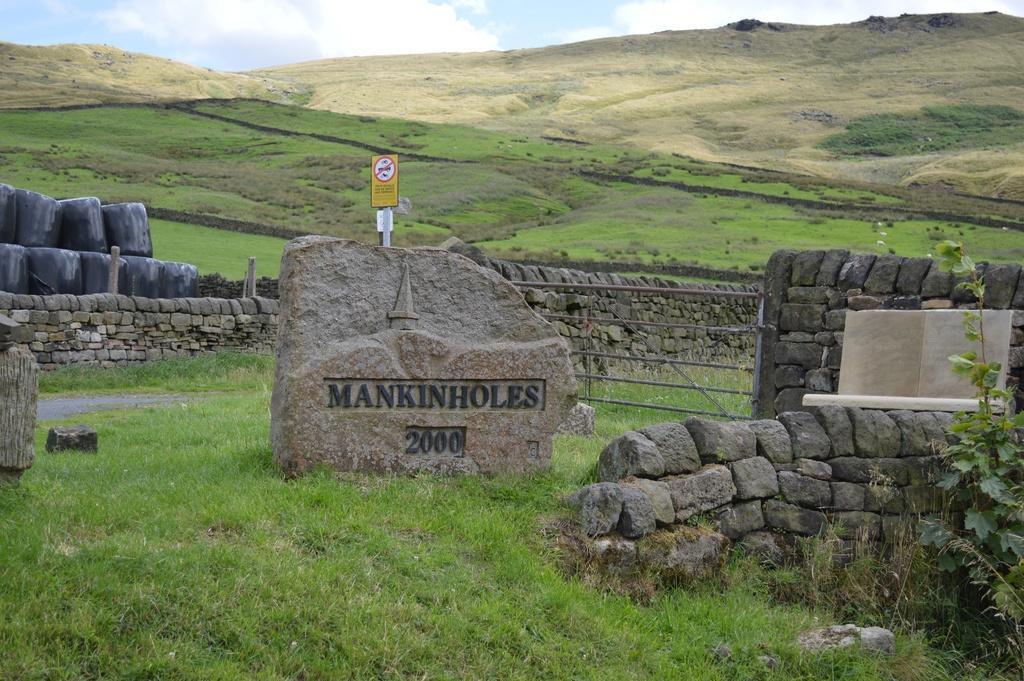How would you summarize this image in a sentence or two? There is a headstone in the center of the image on the grassland and there is a sign pole behind it. There are stones and greenery in the image and there is sky at the top side. 